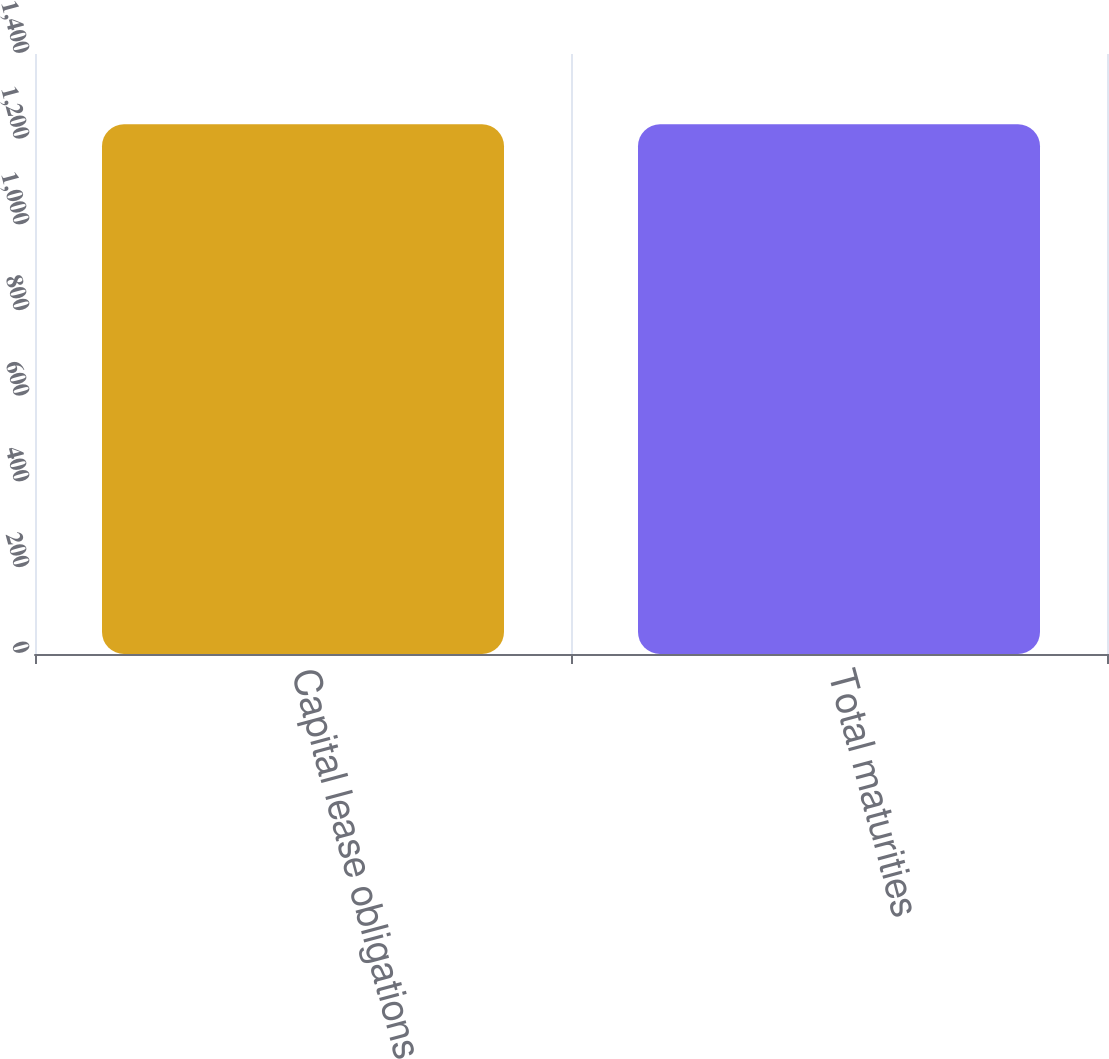<chart> <loc_0><loc_0><loc_500><loc_500><bar_chart><fcel>Capital lease obligations<fcel>Total maturities<nl><fcel>1236<fcel>1236.1<nl></chart> 